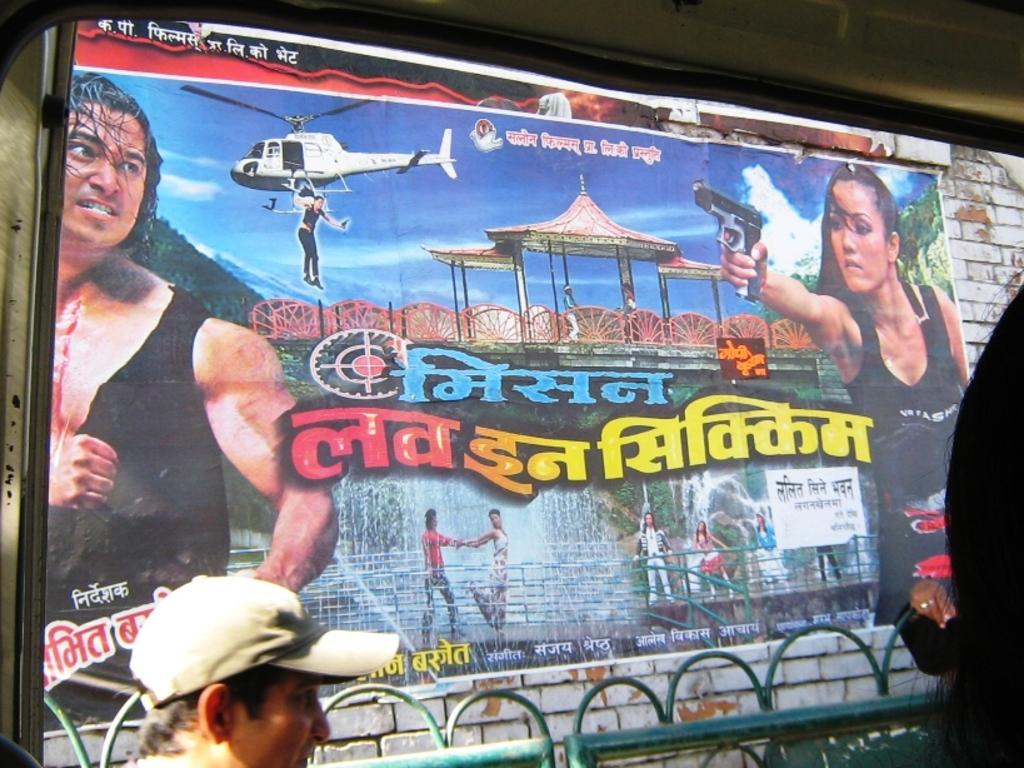Who or what is present in the image? There is a person in the image. What can be seen in the background of the image? There is a poster in the background of the image. What is depicted on the poster? The poster contains images of persons, water, and the sky. How does the wind affect the hole in the image? There is no wind or hole present in the image. 